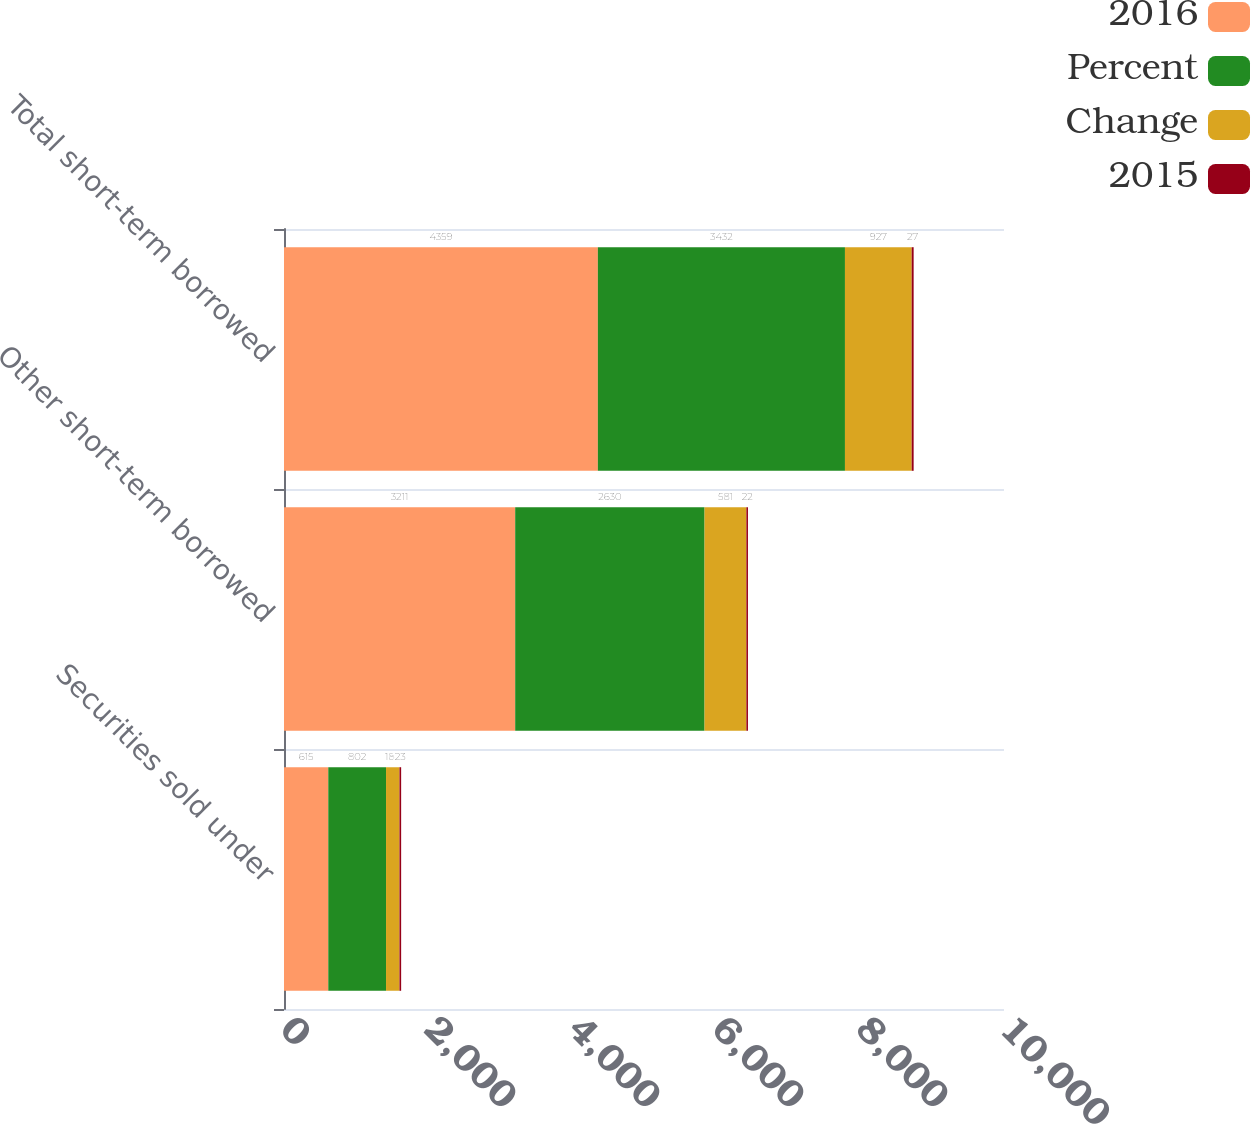Convert chart. <chart><loc_0><loc_0><loc_500><loc_500><stacked_bar_chart><ecel><fcel>Securities sold under<fcel>Other short-term borrowed<fcel>Total short-term borrowed<nl><fcel>2016<fcel>615<fcel>3211<fcel>4359<nl><fcel>Percent<fcel>802<fcel>2630<fcel>3432<nl><fcel>Change<fcel>187<fcel>581<fcel>927<nl><fcel>2015<fcel>23<fcel>22<fcel>27<nl></chart> 